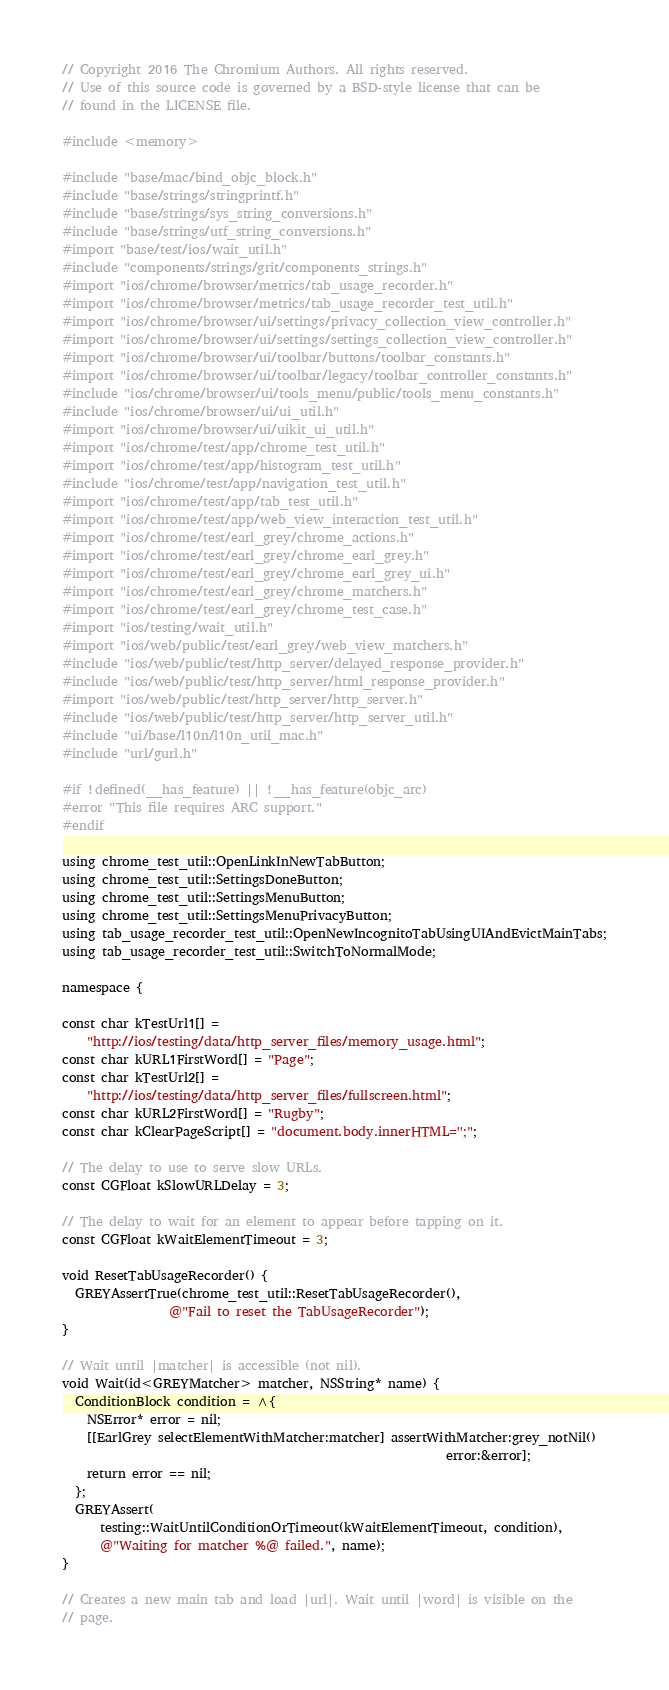Convert code to text. <code><loc_0><loc_0><loc_500><loc_500><_ObjectiveC_>// Copyright 2016 The Chromium Authors. All rights reserved.
// Use of this source code is governed by a BSD-style license that can be
// found in the LICENSE file.

#include <memory>

#include "base/mac/bind_objc_block.h"
#include "base/strings/stringprintf.h"
#include "base/strings/sys_string_conversions.h"
#include "base/strings/utf_string_conversions.h"
#import "base/test/ios/wait_util.h"
#include "components/strings/grit/components_strings.h"
#import "ios/chrome/browser/metrics/tab_usage_recorder.h"
#import "ios/chrome/browser/metrics/tab_usage_recorder_test_util.h"
#import "ios/chrome/browser/ui/settings/privacy_collection_view_controller.h"
#import "ios/chrome/browser/ui/settings/settings_collection_view_controller.h"
#import "ios/chrome/browser/ui/toolbar/buttons/toolbar_constants.h"
#import "ios/chrome/browser/ui/toolbar/legacy/toolbar_controller_constants.h"
#include "ios/chrome/browser/ui/tools_menu/public/tools_menu_constants.h"
#include "ios/chrome/browser/ui/ui_util.h"
#import "ios/chrome/browser/ui/uikit_ui_util.h"
#import "ios/chrome/test/app/chrome_test_util.h"
#import "ios/chrome/test/app/histogram_test_util.h"
#include "ios/chrome/test/app/navigation_test_util.h"
#import "ios/chrome/test/app/tab_test_util.h"
#import "ios/chrome/test/app/web_view_interaction_test_util.h"
#import "ios/chrome/test/earl_grey/chrome_actions.h"
#import "ios/chrome/test/earl_grey/chrome_earl_grey.h"
#import "ios/chrome/test/earl_grey/chrome_earl_grey_ui.h"
#import "ios/chrome/test/earl_grey/chrome_matchers.h"
#import "ios/chrome/test/earl_grey/chrome_test_case.h"
#import "ios/testing/wait_util.h"
#import "ios/web/public/test/earl_grey/web_view_matchers.h"
#include "ios/web/public/test/http_server/delayed_response_provider.h"
#include "ios/web/public/test/http_server/html_response_provider.h"
#import "ios/web/public/test/http_server/http_server.h"
#include "ios/web/public/test/http_server/http_server_util.h"
#include "ui/base/l10n/l10n_util_mac.h"
#include "url/gurl.h"

#if !defined(__has_feature) || !__has_feature(objc_arc)
#error "This file requires ARC support."
#endif

using chrome_test_util::OpenLinkInNewTabButton;
using chrome_test_util::SettingsDoneButton;
using chrome_test_util::SettingsMenuButton;
using chrome_test_util::SettingsMenuPrivacyButton;
using tab_usage_recorder_test_util::OpenNewIncognitoTabUsingUIAndEvictMainTabs;
using tab_usage_recorder_test_util::SwitchToNormalMode;

namespace {

const char kTestUrl1[] =
    "http://ios/testing/data/http_server_files/memory_usage.html";
const char kURL1FirstWord[] = "Page";
const char kTestUrl2[] =
    "http://ios/testing/data/http_server_files/fullscreen.html";
const char kURL2FirstWord[] = "Rugby";
const char kClearPageScript[] = "document.body.innerHTML='';";

// The delay to use to serve slow URLs.
const CGFloat kSlowURLDelay = 3;

// The delay to wait for an element to appear before tapping on it.
const CGFloat kWaitElementTimeout = 3;

void ResetTabUsageRecorder() {
  GREYAssertTrue(chrome_test_util::ResetTabUsageRecorder(),
                 @"Fail to reset the TabUsageRecorder");
}

// Wait until |matcher| is accessible (not nil).
void Wait(id<GREYMatcher> matcher, NSString* name) {
  ConditionBlock condition = ^{
    NSError* error = nil;
    [[EarlGrey selectElementWithMatcher:matcher] assertWithMatcher:grey_notNil()
                                                             error:&error];
    return error == nil;
  };
  GREYAssert(
      testing::WaitUntilConditionOrTimeout(kWaitElementTimeout, condition),
      @"Waiting for matcher %@ failed.", name);
}

// Creates a new main tab and load |url|. Wait until |word| is visible on the
// page.</code> 